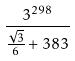<formula> <loc_0><loc_0><loc_500><loc_500>\frac { 3 ^ { 2 9 8 } } { \frac { \sqrt { 3 } } { 6 } + 3 8 3 }</formula> 